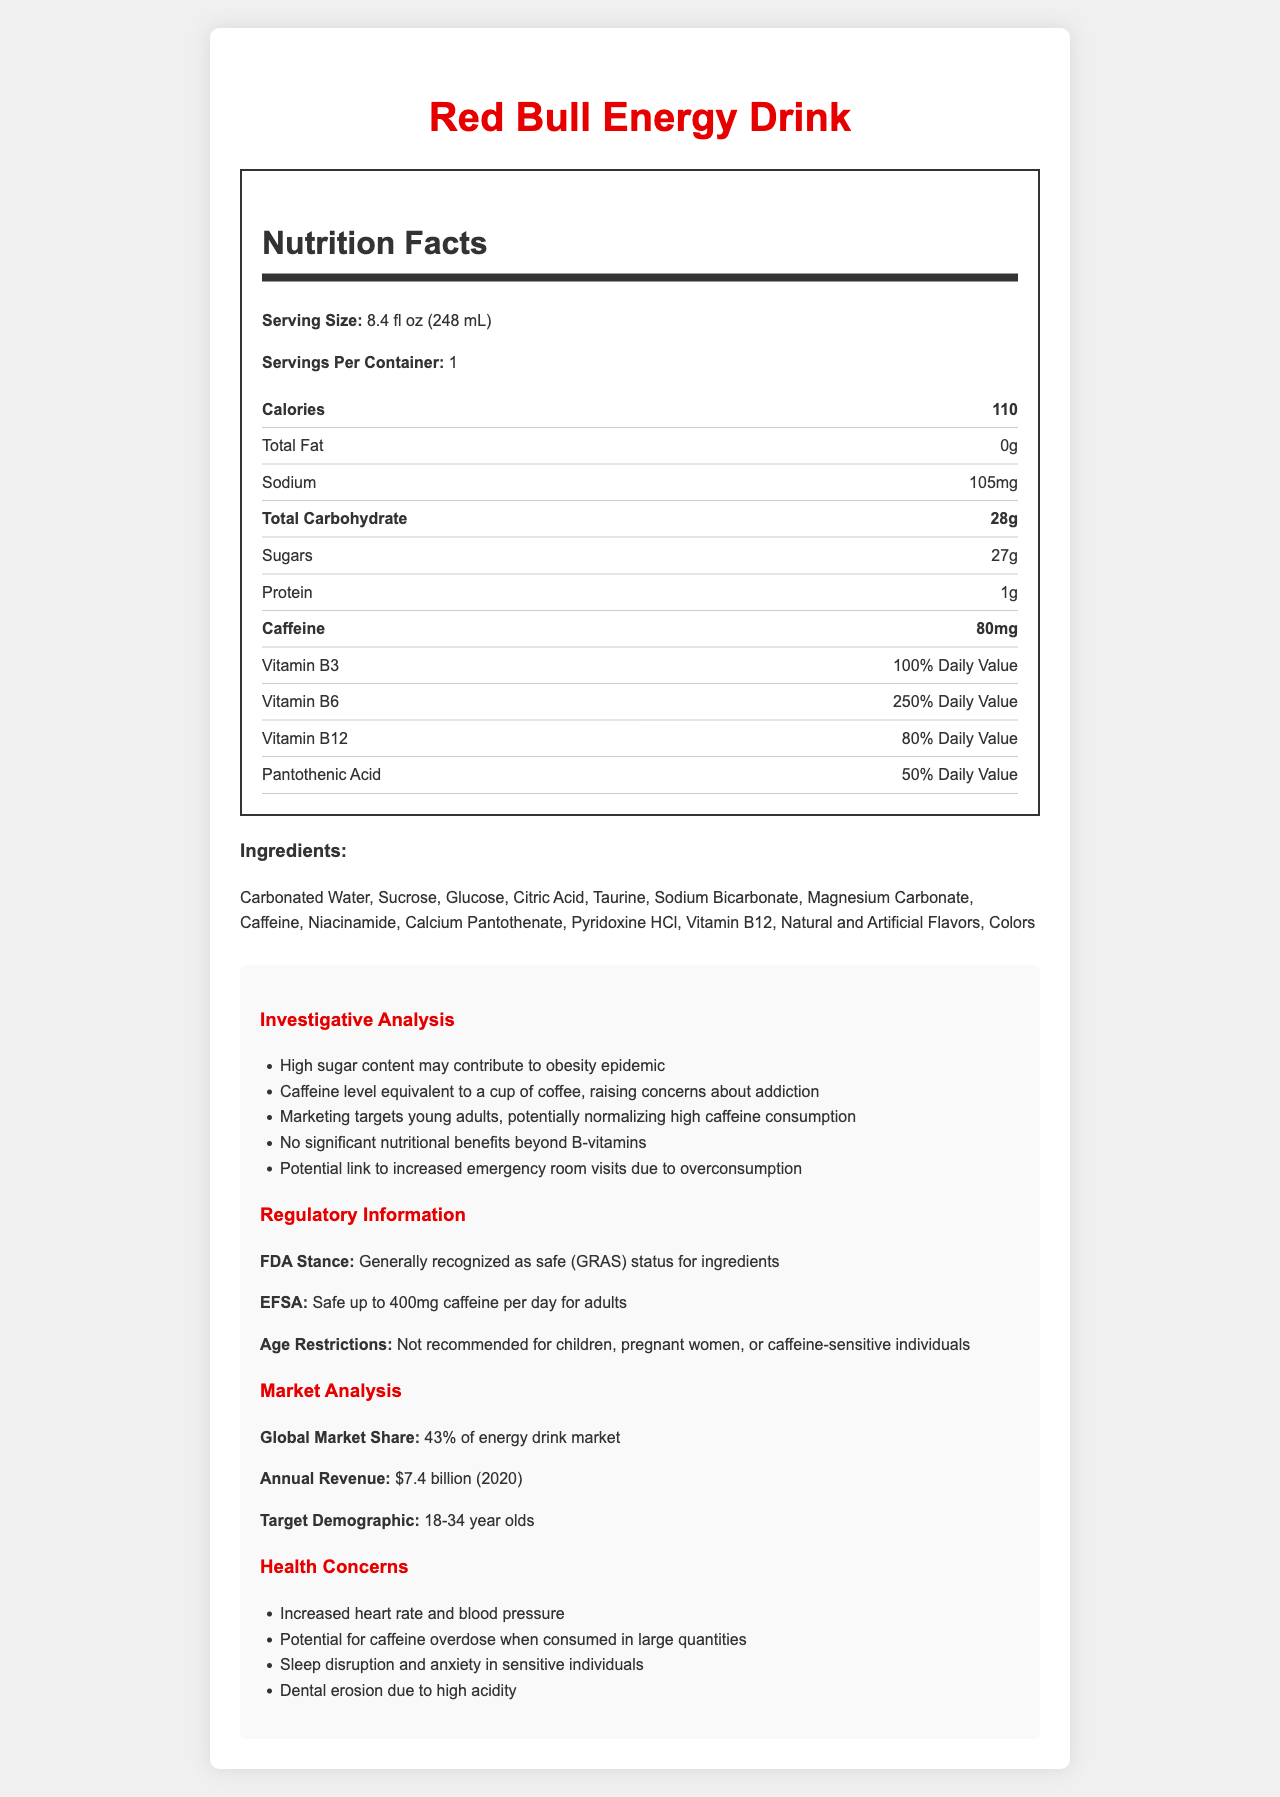what is the serving size of the Red Bull Energy Drink? The serving size is clearly mentioned in the nutrition label as "8.4 fl oz (248 mL)".
Answer: 8.4 fl oz (248 mL) how much caffeine does one serving of Red Bull contain? The caffeine content per serving is labeled as 80mg on the nutrition facts label.
Answer: 80mg how many calories are in one serving of Red Bull? The nutrition label specifies that there are 110 calories per serving.
Answer: 110 what is the total carbohydrate content in one serving of Red Bull? The total carbohydrate content is listed as 28g in the nutrition facts label.
Answer: 28g list three vitamins found in Red Bull and their daily values. The nutrition label provides the daily values for these vitamins: Vitamin B3 at 100%, Vitamin B6 at 250%, and Vitamin B12 at 80%.
Answer: Vitamin B3 (100% Daily Value), Vitamin B6 (250% Daily Value), Vitamin B12 (80% Daily Value) which of the following ingredients is NOT in Red Bull? A. Sucrose B. Glucose C. Salt D. Taurine The ingredient list includes Sucrose, Glucose, and Taurine but does not mention Salt.
Answer: C. Salt what percentage of the global energy drink market does Red Bull hold? A. 25% B. 43% C. 50% D. 60% The market analysis section states that Red Bull holds 43% of the energy drink market.
Answer: B. 43% based on the document, is Red Bull recommended for children or pregnant women? The regulatory information specifies that the drink is not recommended for children, pregnant women, or caffeine-sensitive individuals.
Answer: No can consuming Red Bull potentially lead to increased emergency room visits? One of the investigative notes mentions a potential link to increased emergency room visits due to overconsumption.
Answer: Yes summarize the main health concerns associated with Red Bull as outlined in the document. The health concerns mentioned include increased heart rate and blood pressure, potential for caffeine overdose when consumed in large quantities, sleep disruption and anxiety in sensitive individuals, and dental erosion due to high acidity.
Answer: Increased heart rate and blood pressure, potential for caffeine overdose, sleep disruption and anxiety, dental erosion what ingredient gives Red Bull its flavor? The document lists "Natural and Artificial Flavors" but does not specify which specific ingredients give Red Bull its flavor.
Answer: Not enough information 